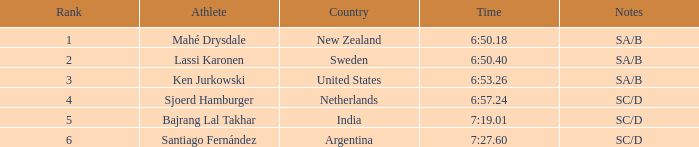What is the highest rank for the team that raced a time of 6:50.40? 2.0. 